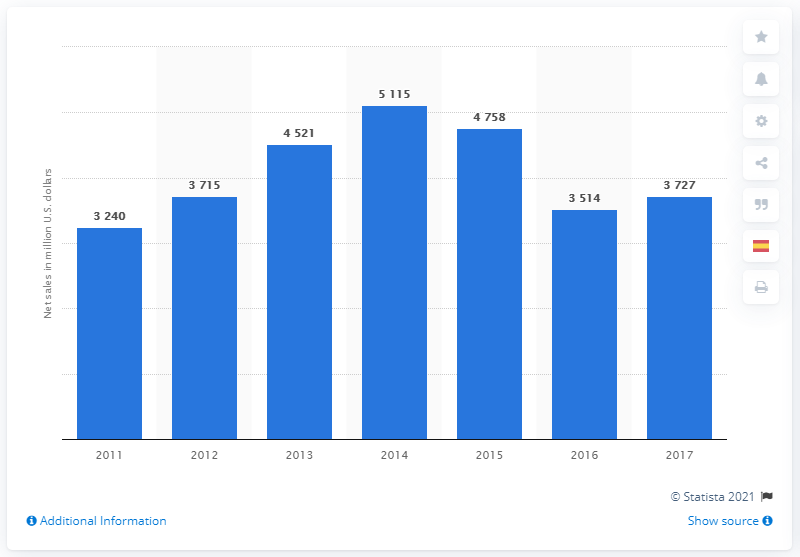Indicate a few pertinent items in this graphic. In 2017, the net sales of the agricultural productivity segment were 3,727. 